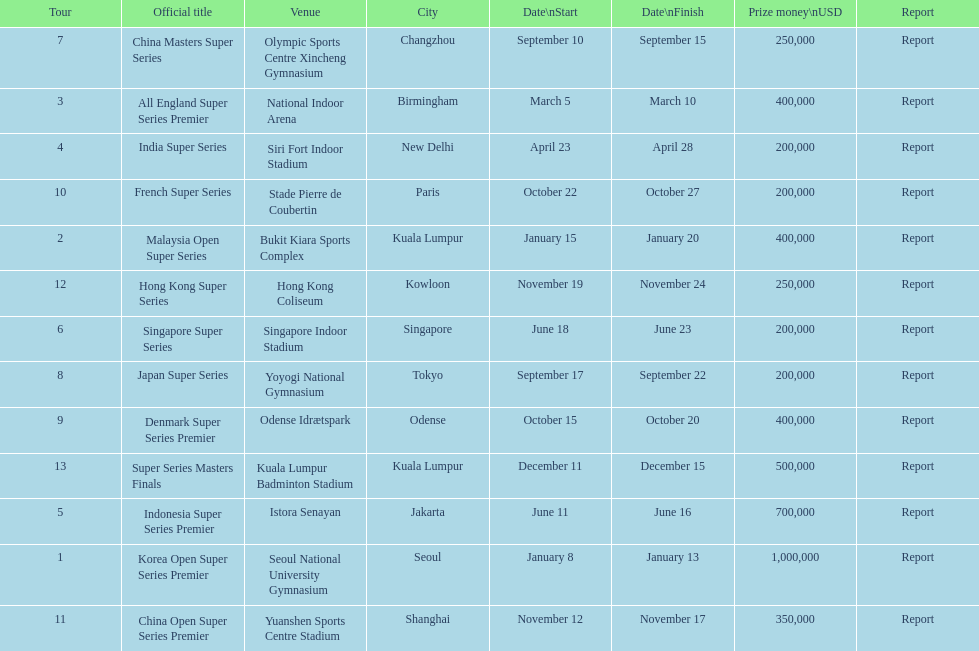How many events of the 2013 bwf super series pay over $200,000? 9. 